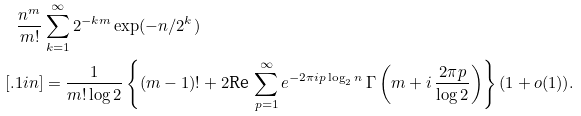Convert formula to latex. <formula><loc_0><loc_0><loc_500><loc_500>\frac { n ^ { m } } { m ! } & \sum _ { k = 1 } ^ { \infty } 2 ^ { - k m } \exp ( - n / 2 ^ { k } ) \\ [ . 1 i n ] & = \frac { 1 } { m ! \log 2 } \left \{ ( m - 1 ) ! + 2 \text {Re} \, \sum _ { p = 1 } ^ { \infty } e ^ { - 2 \pi i p \log _ { 2 } n } \, \Gamma \left ( m + i \, \frac { 2 \pi p } { \log 2 } \right ) \right \} ( 1 + o ( 1 ) ) .</formula> 